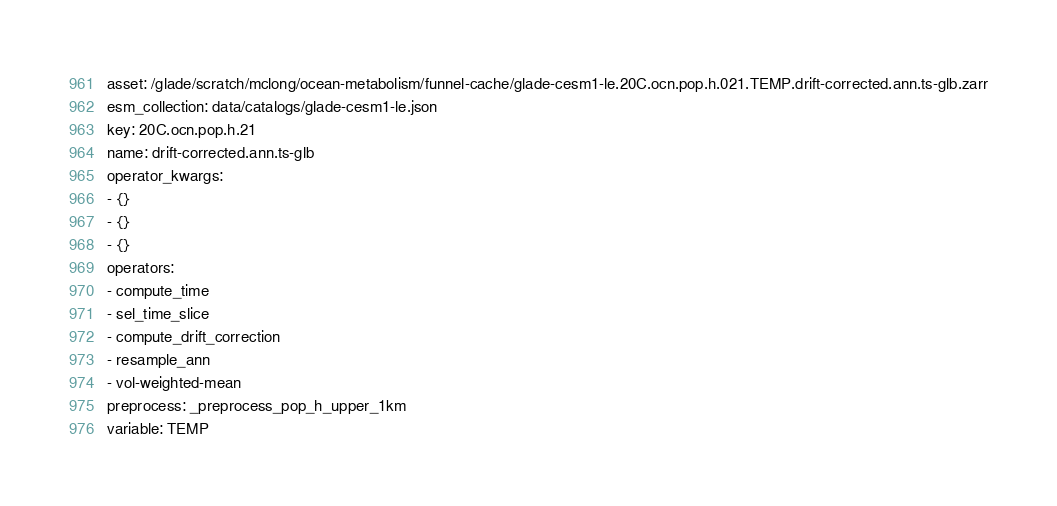Convert code to text. <code><loc_0><loc_0><loc_500><loc_500><_YAML_>asset: /glade/scratch/mclong/ocean-metabolism/funnel-cache/glade-cesm1-le.20C.ocn.pop.h.021.TEMP.drift-corrected.ann.ts-glb.zarr
esm_collection: data/catalogs/glade-cesm1-le.json
key: 20C.ocn.pop.h.21
name: drift-corrected.ann.ts-glb
operator_kwargs:
- {}
- {}
- {}
operators:
- compute_time
- sel_time_slice
- compute_drift_correction
- resample_ann
- vol-weighted-mean
preprocess: _preprocess_pop_h_upper_1km
variable: TEMP
</code> 